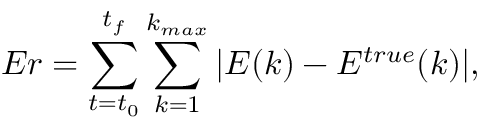<formula> <loc_0><loc_0><loc_500><loc_500>E r = \sum _ { t = t _ { 0 } } ^ { t _ { f } } \sum _ { k = 1 } ^ { k _ { \max } } | E ( k ) - E ^ { t r u e } ( k ) | ,</formula> 